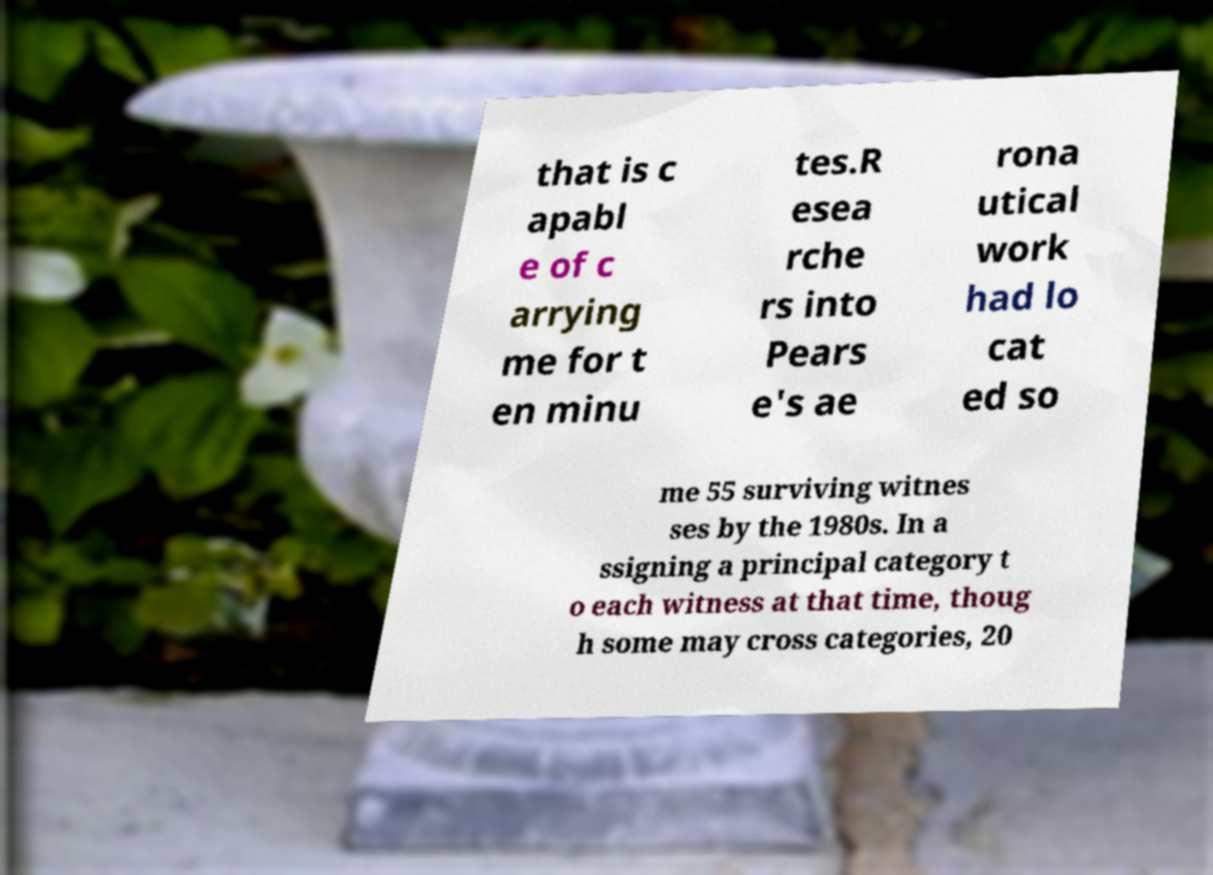Please read and relay the text visible in this image. What does it say? that is c apabl e of c arrying me for t en minu tes.R esea rche rs into Pears e's ae rona utical work had lo cat ed so me 55 surviving witnes ses by the 1980s. In a ssigning a principal category t o each witness at that time, thoug h some may cross categories, 20 